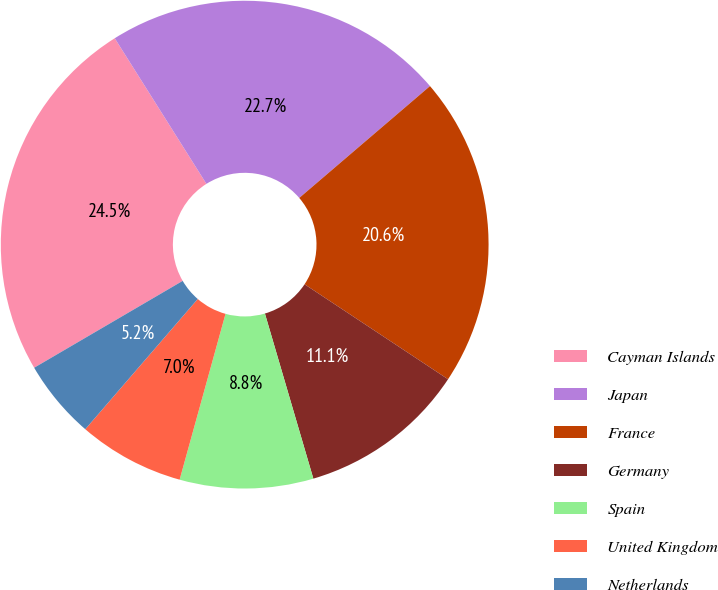Convert chart. <chart><loc_0><loc_0><loc_500><loc_500><pie_chart><fcel>Cayman Islands<fcel>Japan<fcel>France<fcel>Germany<fcel>Spain<fcel>United Kingdom<fcel>Netherlands<nl><fcel>24.48%<fcel>22.68%<fcel>20.57%<fcel>11.15%<fcel>8.84%<fcel>7.04%<fcel>5.24%<nl></chart> 